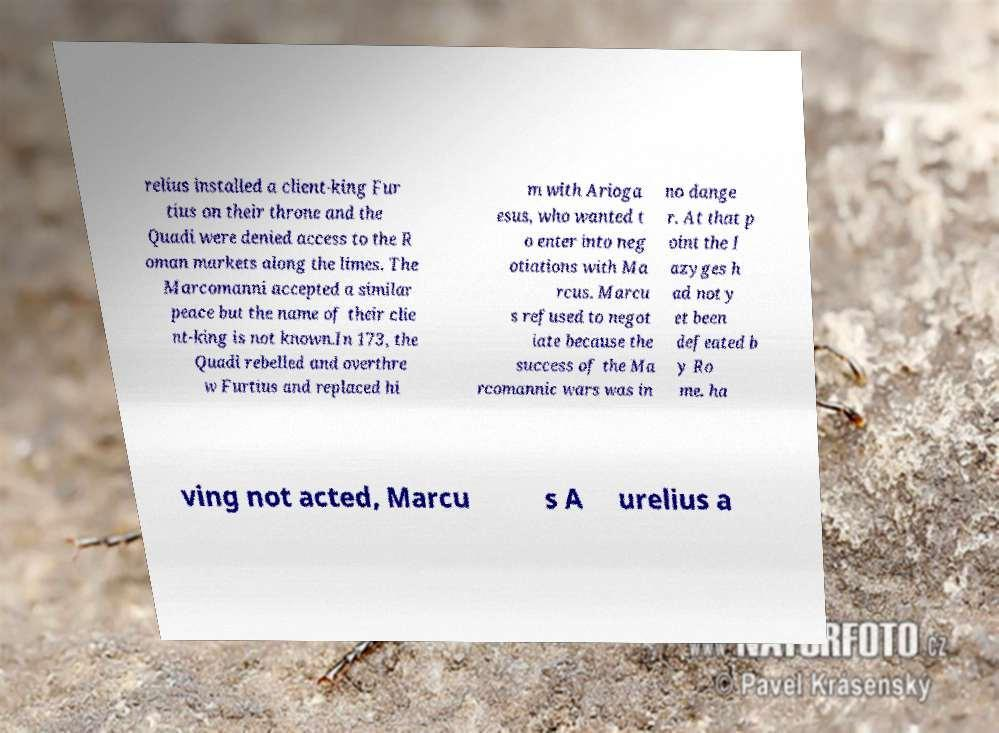What messages or text are displayed in this image? I need them in a readable, typed format. relius installed a client-king Fur tius on their throne and the Quadi were denied access to the R oman markets along the limes. The Marcomanni accepted a similar peace but the name of their clie nt-king is not known.In 173, the Quadi rebelled and overthre w Furtius and replaced hi m with Arioga esus, who wanted t o enter into neg otiations with Ma rcus. Marcu s refused to negot iate because the success of the Ma rcomannic wars was in no dange r. At that p oint the I azyges h ad not y et been defeated b y Ro me. ha ving not acted, Marcu s A urelius a 